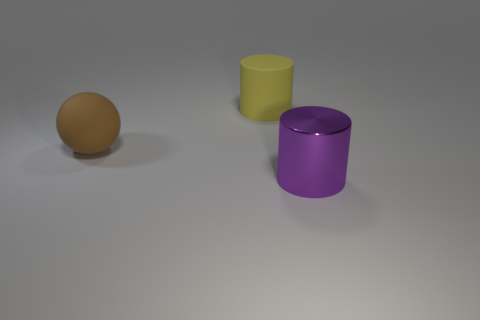There is a matte object in front of the yellow cylinder; are there any large brown matte spheres that are to the left of it?
Ensure brevity in your answer.  No. How big is the object that is behind the big purple cylinder and in front of the yellow matte thing?
Keep it short and to the point. Large. What number of cyan objects are either big objects or rubber objects?
Offer a terse response. 0. There is a purple object that is the same size as the yellow thing; what shape is it?
Your response must be concise. Cylinder. How many other things are the same color as the shiny cylinder?
Make the answer very short. 0. There is a matte object in front of the big matte object right of the brown thing; how big is it?
Keep it short and to the point. Large. Is the material of the large cylinder in front of the brown thing the same as the yellow cylinder?
Your answer should be compact. No. There is a large matte object that is on the right side of the large brown thing; what shape is it?
Your answer should be very brief. Cylinder. How many other cylinders have the same size as the purple metal cylinder?
Your answer should be compact. 1. What size is the yellow cylinder?
Provide a short and direct response. Large. 